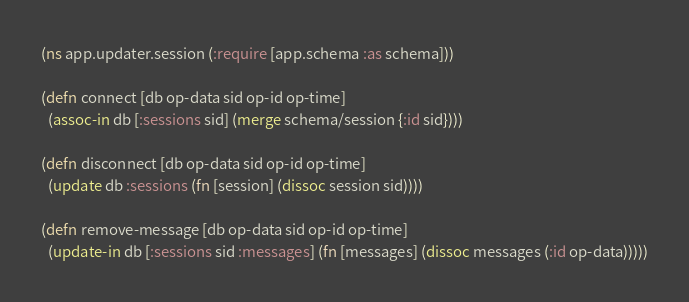Convert code to text. <code><loc_0><loc_0><loc_500><loc_500><_Clojure_>
(ns app.updater.session (:require [app.schema :as schema]))

(defn connect [db op-data sid op-id op-time]
  (assoc-in db [:sessions sid] (merge schema/session {:id sid})))

(defn disconnect [db op-data sid op-id op-time]
  (update db :sessions (fn [session] (dissoc session sid))))

(defn remove-message [db op-data sid op-id op-time]
  (update-in db [:sessions sid :messages] (fn [messages] (dissoc messages (:id op-data)))))
</code> 